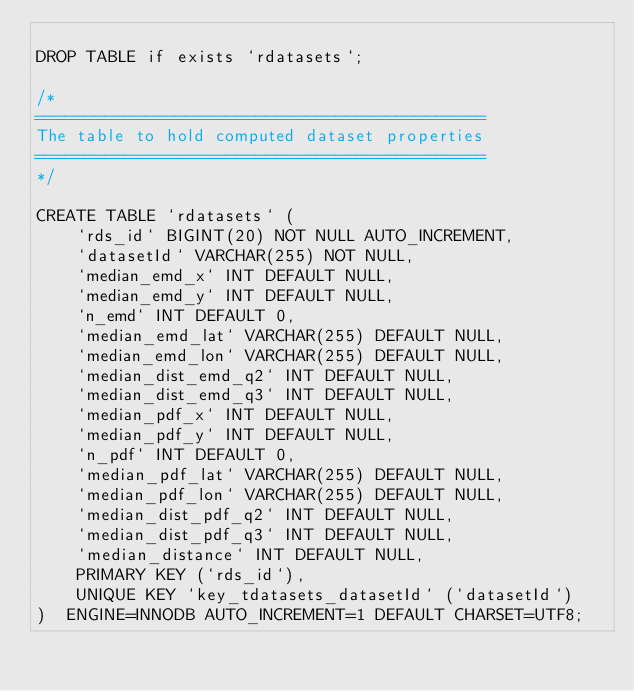<code> <loc_0><loc_0><loc_500><loc_500><_SQL_>
DROP TABLE if exists `rdatasets`;

/* 
=============================================
The table to hold computed dataset properties 
=============================================
*/

CREATE TABLE `rdatasets` (
    `rds_id` BIGINT(20) NOT NULL AUTO_INCREMENT,
    `datasetId` VARCHAR(255) NOT NULL,
    `median_emd_x` INT DEFAULT NULL,
    `median_emd_y` INT DEFAULT NULL,
    `n_emd` INT DEFAULT 0,
    `median_emd_lat` VARCHAR(255) DEFAULT NULL,
    `median_emd_lon` VARCHAR(255) DEFAULT NULL,
    `median_dist_emd_q2` INT DEFAULT NULL,
    `median_dist_emd_q3` INT DEFAULT NULL,
    `median_pdf_x` INT DEFAULT NULL,
    `median_pdf_y` INT DEFAULT NULL,
    `n_pdf` INT DEFAULT 0,
    `median_pdf_lat` VARCHAR(255) DEFAULT NULL,
    `median_pdf_lon` VARCHAR(255) DEFAULT NULL,
    `median_dist_pdf_q2` INT DEFAULT NULL,
    `median_dist_pdf_q3` INT DEFAULT NULL,
    `median_distance` INT DEFAULT NULL,
    PRIMARY KEY (`rds_id`),
    UNIQUE KEY `key_tdatasets_datasetId` (`datasetId`)
)  ENGINE=INNODB AUTO_INCREMENT=1 DEFAULT CHARSET=UTF8;</code> 